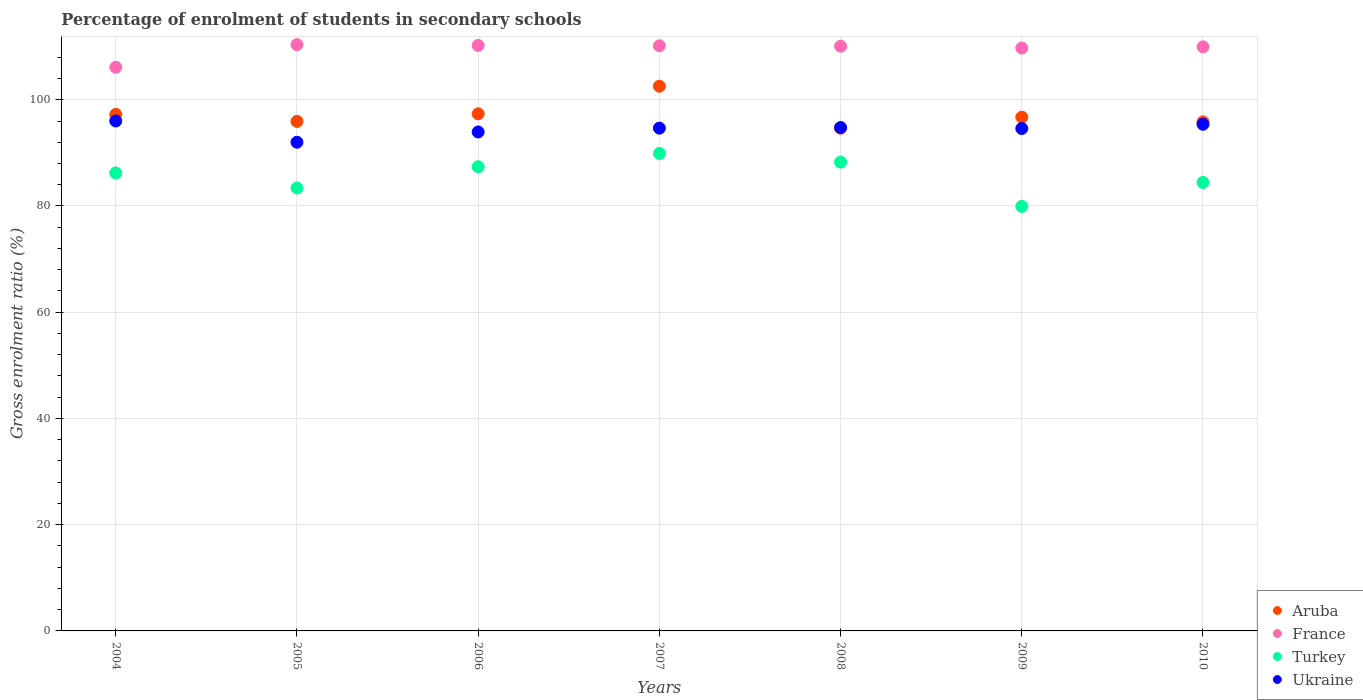How many different coloured dotlines are there?
Provide a short and direct response. 4. What is the percentage of students enrolled in secondary schools in Ukraine in 2007?
Provide a succinct answer. 94.66. Across all years, what is the maximum percentage of students enrolled in secondary schools in Turkey?
Offer a very short reply. 89.89. Across all years, what is the minimum percentage of students enrolled in secondary schools in Turkey?
Your response must be concise. 79.92. In which year was the percentage of students enrolled in secondary schools in Aruba maximum?
Your response must be concise. 2007. In which year was the percentage of students enrolled in secondary schools in Ukraine minimum?
Give a very brief answer. 2005. What is the total percentage of students enrolled in secondary schools in Turkey in the graph?
Offer a very short reply. 599.5. What is the difference between the percentage of students enrolled in secondary schools in Ukraine in 2007 and that in 2008?
Your response must be concise. -0.12. What is the difference between the percentage of students enrolled in secondary schools in Turkey in 2005 and the percentage of students enrolled in secondary schools in France in 2008?
Provide a succinct answer. -26.69. What is the average percentage of students enrolled in secondary schools in France per year?
Offer a very short reply. 109.52. In the year 2007, what is the difference between the percentage of students enrolled in secondary schools in Turkey and percentage of students enrolled in secondary schools in France?
Ensure brevity in your answer.  -20.26. In how many years, is the percentage of students enrolled in secondary schools in Aruba greater than 56 %?
Make the answer very short. 7. What is the ratio of the percentage of students enrolled in secondary schools in Aruba in 2004 to that in 2005?
Your response must be concise. 1.01. Is the percentage of students enrolled in secondary schools in Aruba in 2006 less than that in 2009?
Your answer should be very brief. No. What is the difference between the highest and the second highest percentage of students enrolled in secondary schools in Aruba?
Give a very brief answer. 5.19. What is the difference between the highest and the lowest percentage of students enrolled in secondary schools in Ukraine?
Your response must be concise. 4. Is the sum of the percentage of students enrolled in secondary schools in Turkey in 2008 and 2009 greater than the maximum percentage of students enrolled in secondary schools in France across all years?
Provide a succinct answer. Yes. Is the percentage of students enrolled in secondary schools in Aruba strictly greater than the percentage of students enrolled in secondary schools in Ukraine over the years?
Provide a short and direct response. No. How many years are there in the graph?
Keep it short and to the point. 7. Does the graph contain any zero values?
Offer a terse response. No. Where does the legend appear in the graph?
Make the answer very short. Bottom right. What is the title of the graph?
Give a very brief answer. Percentage of enrolment of students in secondary schools. What is the label or title of the X-axis?
Offer a very short reply. Years. What is the label or title of the Y-axis?
Offer a terse response. Gross enrolment ratio (%). What is the Gross enrolment ratio (%) of Aruba in 2004?
Your answer should be compact. 97.25. What is the Gross enrolment ratio (%) in France in 2004?
Your answer should be compact. 106.12. What is the Gross enrolment ratio (%) in Turkey in 2004?
Provide a short and direct response. 86.22. What is the Gross enrolment ratio (%) of Ukraine in 2004?
Offer a terse response. 96.01. What is the Gross enrolment ratio (%) of Aruba in 2005?
Your answer should be compact. 95.93. What is the Gross enrolment ratio (%) of France in 2005?
Keep it short and to the point. 110.37. What is the Gross enrolment ratio (%) in Turkey in 2005?
Your answer should be very brief. 83.39. What is the Gross enrolment ratio (%) in Ukraine in 2005?
Give a very brief answer. 92. What is the Gross enrolment ratio (%) of Aruba in 2006?
Provide a short and direct response. 97.36. What is the Gross enrolment ratio (%) in France in 2006?
Provide a succinct answer. 110.23. What is the Gross enrolment ratio (%) of Turkey in 2006?
Your response must be concise. 87.38. What is the Gross enrolment ratio (%) of Ukraine in 2006?
Your answer should be very brief. 93.94. What is the Gross enrolment ratio (%) of Aruba in 2007?
Give a very brief answer. 102.55. What is the Gross enrolment ratio (%) in France in 2007?
Your response must be concise. 110.16. What is the Gross enrolment ratio (%) of Turkey in 2007?
Ensure brevity in your answer.  89.89. What is the Gross enrolment ratio (%) of Ukraine in 2007?
Offer a very short reply. 94.66. What is the Gross enrolment ratio (%) of Aruba in 2008?
Offer a very short reply. 94.65. What is the Gross enrolment ratio (%) in France in 2008?
Make the answer very short. 110.08. What is the Gross enrolment ratio (%) of Turkey in 2008?
Give a very brief answer. 88.27. What is the Gross enrolment ratio (%) of Ukraine in 2008?
Your answer should be compact. 94.77. What is the Gross enrolment ratio (%) in Aruba in 2009?
Your response must be concise. 96.72. What is the Gross enrolment ratio (%) of France in 2009?
Ensure brevity in your answer.  109.75. What is the Gross enrolment ratio (%) in Turkey in 2009?
Give a very brief answer. 79.92. What is the Gross enrolment ratio (%) in Ukraine in 2009?
Your answer should be compact. 94.59. What is the Gross enrolment ratio (%) in Aruba in 2010?
Your answer should be compact. 95.84. What is the Gross enrolment ratio (%) in France in 2010?
Offer a very short reply. 109.96. What is the Gross enrolment ratio (%) of Turkey in 2010?
Give a very brief answer. 84.43. What is the Gross enrolment ratio (%) in Ukraine in 2010?
Provide a short and direct response. 95.39. Across all years, what is the maximum Gross enrolment ratio (%) in Aruba?
Keep it short and to the point. 102.55. Across all years, what is the maximum Gross enrolment ratio (%) of France?
Keep it short and to the point. 110.37. Across all years, what is the maximum Gross enrolment ratio (%) in Turkey?
Your response must be concise. 89.89. Across all years, what is the maximum Gross enrolment ratio (%) in Ukraine?
Offer a very short reply. 96.01. Across all years, what is the minimum Gross enrolment ratio (%) of Aruba?
Ensure brevity in your answer.  94.65. Across all years, what is the minimum Gross enrolment ratio (%) of France?
Offer a very short reply. 106.12. Across all years, what is the minimum Gross enrolment ratio (%) of Turkey?
Provide a succinct answer. 79.92. Across all years, what is the minimum Gross enrolment ratio (%) of Ukraine?
Provide a short and direct response. 92. What is the total Gross enrolment ratio (%) of Aruba in the graph?
Keep it short and to the point. 680.29. What is the total Gross enrolment ratio (%) in France in the graph?
Keep it short and to the point. 766.67. What is the total Gross enrolment ratio (%) of Turkey in the graph?
Your response must be concise. 599.5. What is the total Gross enrolment ratio (%) in Ukraine in the graph?
Make the answer very short. 661.35. What is the difference between the Gross enrolment ratio (%) of Aruba in 2004 and that in 2005?
Provide a short and direct response. 1.32. What is the difference between the Gross enrolment ratio (%) of France in 2004 and that in 2005?
Your response must be concise. -4.25. What is the difference between the Gross enrolment ratio (%) of Turkey in 2004 and that in 2005?
Provide a short and direct response. 2.83. What is the difference between the Gross enrolment ratio (%) in Ukraine in 2004 and that in 2005?
Ensure brevity in your answer.  4. What is the difference between the Gross enrolment ratio (%) of Aruba in 2004 and that in 2006?
Your response must be concise. -0.1. What is the difference between the Gross enrolment ratio (%) of France in 2004 and that in 2006?
Keep it short and to the point. -4.1. What is the difference between the Gross enrolment ratio (%) in Turkey in 2004 and that in 2006?
Keep it short and to the point. -1.16. What is the difference between the Gross enrolment ratio (%) of Ukraine in 2004 and that in 2006?
Give a very brief answer. 2.07. What is the difference between the Gross enrolment ratio (%) in Aruba in 2004 and that in 2007?
Your answer should be very brief. -5.29. What is the difference between the Gross enrolment ratio (%) of France in 2004 and that in 2007?
Offer a very short reply. -4.03. What is the difference between the Gross enrolment ratio (%) of Turkey in 2004 and that in 2007?
Provide a succinct answer. -3.67. What is the difference between the Gross enrolment ratio (%) in Ukraine in 2004 and that in 2007?
Provide a succinct answer. 1.35. What is the difference between the Gross enrolment ratio (%) of Aruba in 2004 and that in 2008?
Make the answer very short. 2.6. What is the difference between the Gross enrolment ratio (%) of France in 2004 and that in 2008?
Offer a terse response. -3.96. What is the difference between the Gross enrolment ratio (%) in Turkey in 2004 and that in 2008?
Provide a short and direct response. -2.04. What is the difference between the Gross enrolment ratio (%) in Ukraine in 2004 and that in 2008?
Your answer should be very brief. 1.23. What is the difference between the Gross enrolment ratio (%) in Aruba in 2004 and that in 2009?
Provide a short and direct response. 0.53. What is the difference between the Gross enrolment ratio (%) in France in 2004 and that in 2009?
Give a very brief answer. -3.62. What is the difference between the Gross enrolment ratio (%) of Turkey in 2004 and that in 2009?
Keep it short and to the point. 6.3. What is the difference between the Gross enrolment ratio (%) of Ukraine in 2004 and that in 2009?
Your answer should be very brief. 1.42. What is the difference between the Gross enrolment ratio (%) in Aruba in 2004 and that in 2010?
Your answer should be very brief. 1.42. What is the difference between the Gross enrolment ratio (%) in France in 2004 and that in 2010?
Your answer should be compact. -3.84. What is the difference between the Gross enrolment ratio (%) in Turkey in 2004 and that in 2010?
Your answer should be very brief. 1.79. What is the difference between the Gross enrolment ratio (%) of Ukraine in 2004 and that in 2010?
Make the answer very short. 0.62. What is the difference between the Gross enrolment ratio (%) of Aruba in 2005 and that in 2006?
Ensure brevity in your answer.  -1.43. What is the difference between the Gross enrolment ratio (%) in France in 2005 and that in 2006?
Give a very brief answer. 0.14. What is the difference between the Gross enrolment ratio (%) of Turkey in 2005 and that in 2006?
Your answer should be compact. -4. What is the difference between the Gross enrolment ratio (%) of Ukraine in 2005 and that in 2006?
Keep it short and to the point. -1.93. What is the difference between the Gross enrolment ratio (%) of Aruba in 2005 and that in 2007?
Provide a short and direct response. -6.62. What is the difference between the Gross enrolment ratio (%) in France in 2005 and that in 2007?
Your answer should be compact. 0.22. What is the difference between the Gross enrolment ratio (%) in Turkey in 2005 and that in 2007?
Give a very brief answer. -6.51. What is the difference between the Gross enrolment ratio (%) in Ukraine in 2005 and that in 2007?
Offer a very short reply. -2.65. What is the difference between the Gross enrolment ratio (%) of Aruba in 2005 and that in 2008?
Offer a very short reply. 1.28. What is the difference between the Gross enrolment ratio (%) in France in 2005 and that in 2008?
Your response must be concise. 0.29. What is the difference between the Gross enrolment ratio (%) in Turkey in 2005 and that in 2008?
Provide a succinct answer. -4.88. What is the difference between the Gross enrolment ratio (%) of Ukraine in 2005 and that in 2008?
Your answer should be very brief. -2.77. What is the difference between the Gross enrolment ratio (%) of Aruba in 2005 and that in 2009?
Offer a very short reply. -0.79. What is the difference between the Gross enrolment ratio (%) of France in 2005 and that in 2009?
Keep it short and to the point. 0.63. What is the difference between the Gross enrolment ratio (%) in Turkey in 2005 and that in 2009?
Offer a terse response. 3.46. What is the difference between the Gross enrolment ratio (%) of Ukraine in 2005 and that in 2009?
Your answer should be compact. -2.58. What is the difference between the Gross enrolment ratio (%) of Aruba in 2005 and that in 2010?
Provide a short and direct response. 0.09. What is the difference between the Gross enrolment ratio (%) of France in 2005 and that in 2010?
Your answer should be very brief. 0.41. What is the difference between the Gross enrolment ratio (%) in Turkey in 2005 and that in 2010?
Offer a very short reply. -1.04. What is the difference between the Gross enrolment ratio (%) in Ukraine in 2005 and that in 2010?
Provide a succinct answer. -3.39. What is the difference between the Gross enrolment ratio (%) in Aruba in 2006 and that in 2007?
Provide a succinct answer. -5.19. What is the difference between the Gross enrolment ratio (%) of France in 2006 and that in 2007?
Provide a succinct answer. 0.07. What is the difference between the Gross enrolment ratio (%) of Turkey in 2006 and that in 2007?
Your response must be concise. -2.51. What is the difference between the Gross enrolment ratio (%) in Ukraine in 2006 and that in 2007?
Ensure brevity in your answer.  -0.72. What is the difference between the Gross enrolment ratio (%) of Aruba in 2006 and that in 2008?
Provide a short and direct response. 2.71. What is the difference between the Gross enrolment ratio (%) of France in 2006 and that in 2008?
Make the answer very short. 0.15. What is the difference between the Gross enrolment ratio (%) of Turkey in 2006 and that in 2008?
Your answer should be compact. -0.88. What is the difference between the Gross enrolment ratio (%) in Ukraine in 2006 and that in 2008?
Ensure brevity in your answer.  -0.83. What is the difference between the Gross enrolment ratio (%) in Aruba in 2006 and that in 2009?
Ensure brevity in your answer.  0.63. What is the difference between the Gross enrolment ratio (%) of France in 2006 and that in 2009?
Ensure brevity in your answer.  0.48. What is the difference between the Gross enrolment ratio (%) of Turkey in 2006 and that in 2009?
Make the answer very short. 7.46. What is the difference between the Gross enrolment ratio (%) of Ukraine in 2006 and that in 2009?
Provide a short and direct response. -0.65. What is the difference between the Gross enrolment ratio (%) of Aruba in 2006 and that in 2010?
Give a very brief answer. 1.52. What is the difference between the Gross enrolment ratio (%) in France in 2006 and that in 2010?
Give a very brief answer. 0.26. What is the difference between the Gross enrolment ratio (%) of Turkey in 2006 and that in 2010?
Your response must be concise. 2.96. What is the difference between the Gross enrolment ratio (%) in Ukraine in 2006 and that in 2010?
Offer a very short reply. -1.45. What is the difference between the Gross enrolment ratio (%) in Aruba in 2007 and that in 2008?
Ensure brevity in your answer.  7.9. What is the difference between the Gross enrolment ratio (%) of France in 2007 and that in 2008?
Your answer should be very brief. 0.08. What is the difference between the Gross enrolment ratio (%) of Turkey in 2007 and that in 2008?
Offer a very short reply. 1.63. What is the difference between the Gross enrolment ratio (%) of Ukraine in 2007 and that in 2008?
Make the answer very short. -0.12. What is the difference between the Gross enrolment ratio (%) of Aruba in 2007 and that in 2009?
Your answer should be very brief. 5.82. What is the difference between the Gross enrolment ratio (%) of France in 2007 and that in 2009?
Keep it short and to the point. 0.41. What is the difference between the Gross enrolment ratio (%) in Turkey in 2007 and that in 2009?
Provide a succinct answer. 9.97. What is the difference between the Gross enrolment ratio (%) in Ukraine in 2007 and that in 2009?
Give a very brief answer. 0.07. What is the difference between the Gross enrolment ratio (%) in Aruba in 2007 and that in 2010?
Your answer should be compact. 6.71. What is the difference between the Gross enrolment ratio (%) of France in 2007 and that in 2010?
Your answer should be very brief. 0.19. What is the difference between the Gross enrolment ratio (%) in Turkey in 2007 and that in 2010?
Your response must be concise. 5.47. What is the difference between the Gross enrolment ratio (%) of Ukraine in 2007 and that in 2010?
Make the answer very short. -0.74. What is the difference between the Gross enrolment ratio (%) in Aruba in 2008 and that in 2009?
Your answer should be compact. -2.07. What is the difference between the Gross enrolment ratio (%) in France in 2008 and that in 2009?
Give a very brief answer. 0.34. What is the difference between the Gross enrolment ratio (%) in Turkey in 2008 and that in 2009?
Your answer should be compact. 8.34. What is the difference between the Gross enrolment ratio (%) of Ukraine in 2008 and that in 2009?
Your answer should be very brief. 0.19. What is the difference between the Gross enrolment ratio (%) in Aruba in 2008 and that in 2010?
Provide a succinct answer. -1.19. What is the difference between the Gross enrolment ratio (%) of France in 2008 and that in 2010?
Provide a short and direct response. 0.12. What is the difference between the Gross enrolment ratio (%) in Turkey in 2008 and that in 2010?
Make the answer very short. 3.84. What is the difference between the Gross enrolment ratio (%) of Ukraine in 2008 and that in 2010?
Ensure brevity in your answer.  -0.62. What is the difference between the Gross enrolment ratio (%) in Aruba in 2009 and that in 2010?
Offer a terse response. 0.89. What is the difference between the Gross enrolment ratio (%) of France in 2009 and that in 2010?
Offer a terse response. -0.22. What is the difference between the Gross enrolment ratio (%) in Turkey in 2009 and that in 2010?
Ensure brevity in your answer.  -4.5. What is the difference between the Gross enrolment ratio (%) of Ukraine in 2009 and that in 2010?
Keep it short and to the point. -0.81. What is the difference between the Gross enrolment ratio (%) in Aruba in 2004 and the Gross enrolment ratio (%) in France in 2005?
Your answer should be very brief. -13.12. What is the difference between the Gross enrolment ratio (%) of Aruba in 2004 and the Gross enrolment ratio (%) of Turkey in 2005?
Give a very brief answer. 13.87. What is the difference between the Gross enrolment ratio (%) of Aruba in 2004 and the Gross enrolment ratio (%) of Ukraine in 2005?
Make the answer very short. 5.25. What is the difference between the Gross enrolment ratio (%) in France in 2004 and the Gross enrolment ratio (%) in Turkey in 2005?
Your answer should be very brief. 22.74. What is the difference between the Gross enrolment ratio (%) of France in 2004 and the Gross enrolment ratio (%) of Ukraine in 2005?
Make the answer very short. 14.12. What is the difference between the Gross enrolment ratio (%) in Turkey in 2004 and the Gross enrolment ratio (%) in Ukraine in 2005?
Offer a very short reply. -5.78. What is the difference between the Gross enrolment ratio (%) in Aruba in 2004 and the Gross enrolment ratio (%) in France in 2006?
Give a very brief answer. -12.98. What is the difference between the Gross enrolment ratio (%) of Aruba in 2004 and the Gross enrolment ratio (%) of Turkey in 2006?
Provide a short and direct response. 9.87. What is the difference between the Gross enrolment ratio (%) in Aruba in 2004 and the Gross enrolment ratio (%) in Ukraine in 2006?
Offer a terse response. 3.31. What is the difference between the Gross enrolment ratio (%) of France in 2004 and the Gross enrolment ratio (%) of Turkey in 2006?
Ensure brevity in your answer.  18.74. What is the difference between the Gross enrolment ratio (%) of France in 2004 and the Gross enrolment ratio (%) of Ukraine in 2006?
Your response must be concise. 12.19. What is the difference between the Gross enrolment ratio (%) of Turkey in 2004 and the Gross enrolment ratio (%) of Ukraine in 2006?
Ensure brevity in your answer.  -7.72. What is the difference between the Gross enrolment ratio (%) of Aruba in 2004 and the Gross enrolment ratio (%) of France in 2007?
Offer a very short reply. -12.91. What is the difference between the Gross enrolment ratio (%) in Aruba in 2004 and the Gross enrolment ratio (%) in Turkey in 2007?
Offer a terse response. 7.36. What is the difference between the Gross enrolment ratio (%) in Aruba in 2004 and the Gross enrolment ratio (%) in Ukraine in 2007?
Provide a short and direct response. 2.6. What is the difference between the Gross enrolment ratio (%) of France in 2004 and the Gross enrolment ratio (%) of Turkey in 2007?
Your answer should be compact. 16.23. What is the difference between the Gross enrolment ratio (%) in France in 2004 and the Gross enrolment ratio (%) in Ukraine in 2007?
Your answer should be compact. 11.47. What is the difference between the Gross enrolment ratio (%) in Turkey in 2004 and the Gross enrolment ratio (%) in Ukraine in 2007?
Provide a succinct answer. -8.43. What is the difference between the Gross enrolment ratio (%) in Aruba in 2004 and the Gross enrolment ratio (%) in France in 2008?
Make the answer very short. -12.83. What is the difference between the Gross enrolment ratio (%) of Aruba in 2004 and the Gross enrolment ratio (%) of Turkey in 2008?
Offer a terse response. 8.99. What is the difference between the Gross enrolment ratio (%) in Aruba in 2004 and the Gross enrolment ratio (%) in Ukraine in 2008?
Offer a very short reply. 2.48. What is the difference between the Gross enrolment ratio (%) of France in 2004 and the Gross enrolment ratio (%) of Turkey in 2008?
Make the answer very short. 17.86. What is the difference between the Gross enrolment ratio (%) of France in 2004 and the Gross enrolment ratio (%) of Ukraine in 2008?
Provide a succinct answer. 11.35. What is the difference between the Gross enrolment ratio (%) of Turkey in 2004 and the Gross enrolment ratio (%) of Ukraine in 2008?
Keep it short and to the point. -8.55. What is the difference between the Gross enrolment ratio (%) of Aruba in 2004 and the Gross enrolment ratio (%) of France in 2009?
Offer a terse response. -12.49. What is the difference between the Gross enrolment ratio (%) in Aruba in 2004 and the Gross enrolment ratio (%) in Turkey in 2009?
Your answer should be very brief. 17.33. What is the difference between the Gross enrolment ratio (%) in Aruba in 2004 and the Gross enrolment ratio (%) in Ukraine in 2009?
Keep it short and to the point. 2.67. What is the difference between the Gross enrolment ratio (%) in France in 2004 and the Gross enrolment ratio (%) in Turkey in 2009?
Provide a succinct answer. 26.2. What is the difference between the Gross enrolment ratio (%) of France in 2004 and the Gross enrolment ratio (%) of Ukraine in 2009?
Your response must be concise. 11.54. What is the difference between the Gross enrolment ratio (%) of Turkey in 2004 and the Gross enrolment ratio (%) of Ukraine in 2009?
Keep it short and to the point. -8.37. What is the difference between the Gross enrolment ratio (%) of Aruba in 2004 and the Gross enrolment ratio (%) of France in 2010?
Ensure brevity in your answer.  -12.71. What is the difference between the Gross enrolment ratio (%) in Aruba in 2004 and the Gross enrolment ratio (%) in Turkey in 2010?
Ensure brevity in your answer.  12.82. What is the difference between the Gross enrolment ratio (%) of Aruba in 2004 and the Gross enrolment ratio (%) of Ukraine in 2010?
Your answer should be compact. 1.86. What is the difference between the Gross enrolment ratio (%) in France in 2004 and the Gross enrolment ratio (%) in Turkey in 2010?
Offer a very short reply. 21.7. What is the difference between the Gross enrolment ratio (%) of France in 2004 and the Gross enrolment ratio (%) of Ukraine in 2010?
Your answer should be compact. 10.73. What is the difference between the Gross enrolment ratio (%) in Turkey in 2004 and the Gross enrolment ratio (%) in Ukraine in 2010?
Make the answer very short. -9.17. What is the difference between the Gross enrolment ratio (%) in Aruba in 2005 and the Gross enrolment ratio (%) in France in 2006?
Your answer should be compact. -14.3. What is the difference between the Gross enrolment ratio (%) in Aruba in 2005 and the Gross enrolment ratio (%) in Turkey in 2006?
Give a very brief answer. 8.55. What is the difference between the Gross enrolment ratio (%) of Aruba in 2005 and the Gross enrolment ratio (%) of Ukraine in 2006?
Provide a short and direct response. 1.99. What is the difference between the Gross enrolment ratio (%) in France in 2005 and the Gross enrolment ratio (%) in Turkey in 2006?
Your answer should be compact. 22.99. What is the difference between the Gross enrolment ratio (%) in France in 2005 and the Gross enrolment ratio (%) in Ukraine in 2006?
Provide a short and direct response. 16.44. What is the difference between the Gross enrolment ratio (%) in Turkey in 2005 and the Gross enrolment ratio (%) in Ukraine in 2006?
Ensure brevity in your answer.  -10.55. What is the difference between the Gross enrolment ratio (%) in Aruba in 2005 and the Gross enrolment ratio (%) in France in 2007?
Offer a very short reply. -14.23. What is the difference between the Gross enrolment ratio (%) of Aruba in 2005 and the Gross enrolment ratio (%) of Turkey in 2007?
Ensure brevity in your answer.  6.04. What is the difference between the Gross enrolment ratio (%) of Aruba in 2005 and the Gross enrolment ratio (%) of Ukraine in 2007?
Offer a terse response. 1.27. What is the difference between the Gross enrolment ratio (%) in France in 2005 and the Gross enrolment ratio (%) in Turkey in 2007?
Keep it short and to the point. 20.48. What is the difference between the Gross enrolment ratio (%) of France in 2005 and the Gross enrolment ratio (%) of Ukraine in 2007?
Ensure brevity in your answer.  15.72. What is the difference between the Gross enrolment ratio (%) of Turkey in 2005 and the Gross enrolment ratio (%) of Ukraine in 2007?
Offer a terse response. -11.27. What is the difference between the Gross enrolment ratio (%) in Aruba in 2005 and the Gross enrolment ratio (%) in France in 2008?
Provide a short and direct response. -14.15. What is the difference between the Gross enrolment ratio (%) of Aruba in 2005 and the Gross enrolment ratio (%) of Turkey in 2008?
Keep it short and to the point. 7.66. What is the difference between the Gross enrolment ratio (%) of Aruba in 2005 and the Gross enrolment ratio (%) of Ukraine in 2008?
Your answer should be compact. 1.16. What is the difference between the Gross enrolment ratio (%) of France in 2005 and the Gross enrolment ratio (%) of Turkey in 2008?
Ensure brevity in your answer.  22.11. What is the difference between the Gross enrolment ratio (%) of France in 2005 and the Gross enrolment ratio (%) of Ukraine in 2008?
Your answer should be very brief. 15.6. What is the difference between the Gross enrolment ratio (%) in Turkey in 2005 and the Gross enrolment ratio (%) in Ukraine in 2008?
Offer a terse response. -11.39. What is the difference between the Gross enrolment ratio (%) of Aruba in 2005 and the Gross enrolment ratio (%) of France in 2009?
Your answer should be very brief. -13.82. What is the difference between the Gross enrolment ratio (%) of Aruba in 2005 and the Gross enrolment ratio (%) of Turkey in 2009?
Your answer should be compact. 16. What is the difference between the Gross enrolment ratio (%) in Aruba in 2005 and the Gross enrolment ratio (%) in Ukraine in 2009?
Offer a terse response. 1.34. What is the difference between the Gross enrolment ratio (%) in France in 2005 and the Gross enrolment ratio (%) in Turkey in 2009?
Give a very brief answer. 30.45. What is the difference between the Gross enrolment ratio (%) of France in 2005 and the Gross enrolment ratio (%) of Ukraine in 2009?
Your response must be concise. 15.79. What is the difference between the Gross enrolment ratio (%) in Turkey in 2005 and the Gross enrolment ratio (%) in Ukraine in 2009?
Give a very brief answer. -11.2. What is the difference between the Gross enrolment ratio (%) of Aruba in 2005 and the Gross enrolment ratio (%) of France in 2010?
Keep it short and to the point. -14.04. What is the difference between the Gross enrolment ratio (%) of Aruba in 2005 and the Gross enrolment ratio (%) of Turkey in 2010?
Keep it short and to the point. 11.5. What is the difference between the Gross enrolment ratio (%) of Aruba in 2005 and the Gross enrolment ratio (%) of Ukraine in 2010?
Offer a terse response. 0.54. What is the difference between the Gross enrolment ratio (%) of France in 2005 and the Gross enrolment ratio (%) of Turkey in 2010?
Your response must be concise. 25.94. What is the difference between the Gross enrolment ratio (%) of France in 2005 and the Gross enrolment ratio (%) of Ukraine in 2010?
Make the answer very short. 14.98. What is the difference between the Gross enrolment ratio (%) in Turkey in 2005 and the Gross enrolment ratio (%) in Ukraine in 2010?
Keep it short and to the point. -12. What is the difference between the Gross enrolment ratio (%) of Aruba in 2006 and the Gross enrolment ratio (%) of France in 2007?
Your response must be concise. -12.8. What is the difference between the Gross enrolment ratio (%) in Aruba in 2006 and the Gross enrolment ratio (%) in Turkey in 2007?
Ensure brevity in your answer.  7.46. What is the difference between the Gross enrolment ratio (%) in Aruba in 2006 and the Gross enrolment ratio (%) in Ukraine in 2007?
Make the answer very short. 2.7. What is the difference between the Gross enrolment ratio (%) of France in 2006 and the Gross enrolment ratio (%) of Turkey in 2007?
Ensure brevity in your answer.  20.33. What is the difference between the Gross enrolment ratio (%) of France in 2006 and the Gross enrolment ratio (%) of Ukraine in 2007?
Your answer should be very brief. 15.57. What is the difference between the Gross enrolment ratio (%) in Turkey in 2006 and the Gross enrolment ratio (%) in Ukraine in 2007?
Provide a succinct answer. -7.27. What is the difference between the Gross enrolment ratio (%) of Aruba in 2006 and the Gross enrolment ratio (%) of France in 2008?
Offer a very short reply. -12.73. What is the difference between the Gross enrolment ratio (%) in Aruba in 2006 and the Gross enrolment ratio (%) in Turkey in 2008?
Your answer should be compact. 9.09. What is the difference between the Gross enrolment ratio (%) in Aruba in 2006 and the Gross enrolment ratio (%) in Ukraine in 2008?
Give a very brief answer. 2.58. What is the difference between the Gross enrolment ratio (%) in France in 2006 and the Gross enrolment ratio (%) in Turkey in 2008?
Your answer should be compact. 21.96. What is the difference between the Gross enrolment ratio (%) in France in 2006 and the Gross enrolment ratio (%) in Ukraine in 2008?
Your response must be concise. 15.46. What is the difference between the Gross enrolment ratio (%) of Turkey in 2006 and the Gross enrolment ratio (%) of Ukraine in 2008?
Your answer should be compact. -7.39. What is the difference between the Gross enrolment ratio (%) of Aruba in 2006 and the Gross enrolment ratio (%) of France in 2009?
Provide a short and direct response. -12.39. What is the difference between the Gross enrolment ratio (%) of Aruba in 2006 and the Gross enrolment ratio (%) of Turkey in 2009?
Make the answer very short. 17.43. What is the difference between the Gross enrolment ratio (%) of Aruba in 2006 and the Gross enrolment ratio (%) of Ukraine in 2009?
Your answer should be very brief. 2.77. What is the difference between the Gross enrolment ratio (%) in France in 2006 and the Gross enrolment ratio (%) in Turkey in 2009?
Make the answer very short. 30.3. What is the difference between the Gross enrolment ratio (%) of France in 2006 and the Gross enrolment ratio (%) of Ukraine in 2009?
Your answer should be compact. 15.64. What is the difference between the Gross enrolment ratio (%) in Turkey in 2006 and the Gross enrolment ratio (%) in Ukraine in 2009?
Provide a succinct answer. -7.2. What is the difference between the Gross enrolment ratio (%) in Aruba in 2006 and the Gross enrolment ratio (%) in France in 2010?
Your answer should be very brief. -12.61. What is the difference between the Gross enrolment ratio (%) of Aruba in 2006 and the Gross enrolment ratio (%) of Turkey in 2010?
Provide a short and direct response. 12.93. What is the difference between the Gross enrolment ratio (%) in Aruba in 2006 and the Gross enrolment ratio (%) in Ukraine in 2010?
Offer a terse response. 1.97. What is the difference between the Gross enrolment ratio (%) of France in 2006 and the Gross enrolment ratio (%) of Turkey in 2010?
Your answer should be very brief. 25.8. What is the difference between the Gross enrolment ratio (%) in France in 2006 and the Gross enrolment ratio (%) in Ukraine in 2010?
Provide a succinct answer. 14.84. What is the difference between the Gross enrolment ratio (%) of Turkey in 2006 and the Gross enrolment ratio (%) of Ukraine in 2010?
Provide a succinct answer. -8.01. What is the difference between the Gross enrolment ratio (%) of Aruba in 2007 and the Gross enrolment ratio (%) of France in 2008?
Your response must be concise. -7.54. What is the difference between the Gross enrolment ratio (%) in Aruba in 2007 and the Gross enrolment ratio (%) in Turkey in 2008?
Provide a short and direct response. 14.28. What is the difference between the Gross enrolment ratio (%) of Aruba in 2007 and the Gross enrolment ratio (%) of Ukraine in 2008?
Your response must be concise. 7.77. What is the difference between the Gross enrolment ratio (%) in France in 2007 and the Gross enrolment ratio (%) in Turkey in 2008?
Ensure brevity in your answer.  21.89. What is the difference between the Gross enrolment ratio (%) of France in 2007 and the Gross enrolment ratio (%) of Ukraine in 2008?
Give a very brief answer. 15.38. What is the difference between the Gross enrolment ratio (%) in Turkey in 2007 and the Gross enrolment ratio (%) in Ukraine in 2008?
Your response must be concise. -4.88. What is the difference between the Gross enrolment ratio (%) of Aruba in 2007 and the Gross enrolment ratio (%) of France in 2009?
Provide a short and direct response. -7.2. What is the difference between the Gross enrolment ratio (%) in Aruba in 2007 and the Gross enrolment ratio (%) in Turkey in 2009?
Provide a succinct answer. 22.62. What is the difference between the Gross enrolment ratio (%) of Aruba in 2007 and the Gross enrolment ratio (%) of Ukraine in 2009?
Your answer should be very brief. 7.96. What is the difference between the Gross enrolment ratio (%) in France in 2007 and the Gross enrolment ratio (%) in Turkey in 2009?
Provide a short and direct response. 30.23. What is the difference between the Gross enrolment ratio (%) of France in 2007 and the Gross enrolment ratio (%) of Ukraine in 2009?
Provide a short and direct response. 15.57. What is the difference between the Gross enrolment ratio (%) of Turkey in 2007 and the Gross enrolment ratio (%) of Ukraine in 2009?
Your response must be concise. -4.69. What is the difference between the Gross enrolment ratio (%) of Aruba in 2007 and the Gross enrolment ratio (%) of France in 2010?
Give a very brief answer. -7.42. What is the difference between the Gross enrolment ratio (%) in Aruba in 2007 and the Gross enrolment ratio (%) in Turkey in 2010?
Give a very brief answer. 18.12. What is the difference between the Gross enrolment ratio (%) of Aruba in 2007 and the Gross enrolment ratio (%) of Ukraine in 2010?
Your answer should be very brief. 7.16. What is the difference between the Gross enrolment ratio (%) of France in 2007 and the Gross enrolment ratio (%) of Turkey in 2010?
Provide a short and direct response. 25.73. What is the difference between the Gross enrolment ratio (%) in France in 2007 and the Gross enrolment ratio (%) in Ukraine in 2010?
Your answer should be very brief. 14.77. What is the difference between the Gross enrolment ratio (%) in Turkey in 2007 and the Gross enrolment ratio (%) in Ukraine in 2010?
Make the answer very short. -5.5. What is the difference between the Gross enrolment ratio (%) of Aruba in 2008 and the Gross enrolment ratio (%) of France in 2009?
Provide a short and direct response. -15.1. What is the difference between the Gross enrolment ratio (%) in Aruba in 2008 and the Gross enrolment ratio (%) in Turkey in 2009?
Make the answer very short. 14.72. What is the difference between the Gross enrolment ratio (%) in Aruba in 2008 and the Gross enrolment ratio (%) in Ukraine in 2009?
Provide a short and direct response. 0.06. What is the difference between the Gross enrolment ratio (%) of France in 2008 and the Gross enrolment ratio (%) of Turkey in 2009?
Make the answer very short. 30.16. What is the difference between the Gross enrolment ratio (%) of France in 2008 and the Gross enrolment ratio (%) of Ukraine in 2009?
Keep it short and to the point. 15.5. What is the difference between the Gross enrolment ratio (%) of Turkey in 2008 and the Gross enrolment ratio (%) of Ukraine in 2009?
Your answer should be compact. -6.32. What is the difference between the Gross enrolment ratio (%) of Aruba in 2008 and the Gross enrolment ratio (%) of France in 2010?
Provide a succinct answer. -15.31. What is the difference between the Gross enrolment ratio (%) of Aruba in 2008 and the Gross enrolment ratio (%) of Turkey in 2010?
Ensure brevity in your answer.  10.22. What is the difference between the Gross enrolment ratio (%) of Aruba in 2008 and the Gross enrolment ratio (%) of Ukraine in 2010?
Your answer should be very brief. -0.74. What is the difference between the Gross enrolment ratio (%) in France in 2008 and the Gross enrolment ratio (%) in Turkey in 2010?
Keep it short and to the point. 25.65. What is the difference between the Gross enrolment ratio (%) of France in 2008 and the Gross enrolment ratio (%) of Ukraine in 2010?
Offer a terse response. 14.69. What is the difference between the Gross enrolment ratio (%) of Turkey in 2008 and the Gross enrolment ratio (%) of Ukraine in 2010?
Provide a succinct answer. -7.13. What is the difference between the Gross enrolment ratio (%) in Aruba in 2009 and the Gross enrolment ratio (%) in France in 2010?
Your response must be concise. -13.24. What is the difference between the Gross enrolment ratio (%) in Aruba in 2009 and the Gross enrolment ratio (%) in Turkey in 2010?
Provide a short and direct response. 12.3. What is the difference between the Gross enrolment ratio (%) of Aruba in 2009 and the Gross enrolment ratio (%) of Ukraine in 2010?
Provide a succinct answer. 1.33. What is the difference between the Gross enrolment ratio (%) of France in 2009 and the Gross enrolment ratio (%) of Turkey in 2010?
Provide a short and direct response. 25.32. What is the difference between the Gross enrolment ratio (%) of France in 2009 and the Gross enrolment ratio (%) of Ukraine in 2010?
Provide a succinct answer. 14.36. What is the difference between the Gross enrolment ratio (%) of Turkey in 2009 and the Gross enrolment ratio (%) of Ukraine in 2010?
Provide a succinct answer. -15.47. What is the average Gross enrolment ratio (%) in Aruba per year?
Offer a terse response. 97.18. What is the average Gross enrolment ratio (%) of France per year?
Provide a succinct answer. 109.52. What is the average Gross enrolment ratio (%) of Turkey per year?
Offer a terse response. 85.64. What is the average Gross enrolment ratio (%) of Ukraine per year?
Your response must be concise. 94.48. In the year 2004, what is the difference between the Gross enrolment ratio (%) of Aruba and Gross enrolment ratio (%) of France?
Offer a terse response. -8.87. In the year 2004, what is the difference between the Gross enrolment ratio (%) in Aruba and Gross enrolment ratio (%) in Turkey?
Your answer should be compact. 11.03. In the year 2004, what is the difference between the Gross enrolment ratio (%) of Aruba and Gross enrolment ratio (%) of Ukraine?
Give a very brief answer. 1.25. In the year 2004, what is the difference between the Gross enrolment ratio (%) in France and Gross enrolment ratio (%) in Turkey?
Ensure brevity in your answer.  19.9. In the year 2004, what is the difference between the Gross enrolment ratio (%) in France and Gross enrolment ratio (%) in Ukraine?
Keep it short and to the point. 10.12. In the year 2004, what is the difference between the Gross enrolment ratio (%) of Turkey and Gross enrolment ratio (%) of Ukraine?
Give a very brief answer. -9.79. In the year 2005, what is the difference between the Gross enrolment ratio (%) of Aruba and Gross enrolment ratio (%) of France?
Make the answer very short. -14.44. In the year 2005, what is the difference between the Gross enrolment ratio (%) of Aruba and Gross enrolment ratio (%) of Turkey?
Make the answer very short. 12.54. In the year 2005, what is the difference between the Gross enrolment ratio (%) in Aruba and Gross enrolment ratio (%) in Ukraine?
Provide a succinct answer. 3.92. In the year 2005, what is the difference between the Gross enrolment ratio (%) of France and Gross enrolment ratio (%) of Turkey?
Provide a succinct answer. 26.99. In the year 2005, what is the difference between the Gross enrolment ratio (%) of France and Gross enrolment ratio (%) of Ukraine?
Your answer should be compact. 18.37. In the year 2005, what is the difference between the Gross enrolment ratio (%) in Turkey and Gross enrolment ratio (%) in Ukraine?
Give a very brief answer. -8.62. In the year 2006, what is the difference between the Gross enrolment ratio (%) of Aruba and Gross enrolment ratio (%) of France?
Offer a terse response. -12.87. In the year 2006, what is the difference between the Gross enrolment ratio (%) of Aruba and Gross enrolment ratio (%) of Turkey?
Provide a succinct answer. 9.97. In the year 2006, what is the difference between the Gross enrolment ratio (%) in Aruba and Gross enrolment ratio (%) in Ukraine?
Offer a terse response. 3.42. In the year 2006, what is the difference between the Gross enrolment ratio (%) in France and Gross enrolment ratio (%) in Turkey?
Your answer should be very brief. 22.84. In the year 2006, what is the difference between the Gross enrolment ratio (%) of France and Gross enrolment ratio (%) of Ukraine?
Provide a short and direct response. 16.29. In the year 2006, what is the difference between the Gross enrolment ratio (%) of Turkey and Gross enrolment ratio (%) of Ukraine?
Keep it short and to the point. -6.55. In the year 2007, what is the difference between the Gross enrolment ratio (%) of Aruba and Gross enrolment ratio (%) of France?
Offer a terse response. -7.61. In the year 2007, what is the difference between the Gross enrolment ratio (%) in Aruba and Gross enrolment ratio (%) in Turkey?
Ensure brevity in your answer.  12.65. In the year 2007, what is the difference between the Gross enrolment ratio (%) in Aruba and Gross enrolment ratio (%) in Ukraine?
Your answer should be compact. 7.89. In the year 2007, what is the difference between the Gross enrolment ratio (%) in France and Gross enrolment ratio (%) in Turkey?
Provide a short and direct response. 20.26. In the year 2007, what is the difference between the Gross enrolment ratio (%) in France and Gross enrolment ratio (%) in Ukraine?
Your answer should be very brief. 15.5. In the year 2007, what is the difference between the Gross enrolment ratio (%) in Turkey and Gross enrolment ratio (%) in Ukraine?
Your answer should be very brief. -4.76. In the year 2008, what is the difference between the Gross enrolment ratio (%) in Aruba and Gross enrolment ratio (%) in France?
Your answer should be very brief. -15.43. In the year 2008, what is the difference between the Gross enrolment ratio (%) of Aruba and Gross enrolment ratio (%) of Turkey?
Ensure brevity in your answer.  6.38. In the year 2008, what is the difference between the Gross enrolment ratio (%) in Aruba and Gross enrolment ratio (%) in Ukraine?
Ensure brevity in your answer.  -0.12. In the year 2008, what is the difference between the Gross enrolment ratio (%) of France and Gross enrolment ratio (%) of Turkey?
Offer a terse response. 21.82. In the year 2008, what is the difference between the Gross enrolment ratio (%) in France and Gross enrolment ratio (%) in Ukraine?
Provide a succinct answer. 15.31. In the year 2008, what is the difference between the Gross enrolment ratio (%) of Turkey and Gross enrolment ratio (%) of Ukraine?
Provide a succinct answer. -6.51. In the year 2009, what is the difference between the Gross enrolment ratio (%) in Aruba and Gross enrolment ratio (%) in France?
Your answer should be very brief. -13.02. In the year 2009, what is the difference between the Gross enrolment ratio (%) in Aruba and Gross enrolment ratio (%) in Turkey?
Your answer should be very brief. 16.8. In the year 2009, what is the difference between the Gross enrolment ratio (%) in Aruba and Gross enrolment ratio (%) in Ukraine?
Make the answer very short. 2.14. In the year 2009, what is the difference between the Gross enrolment ratio (%) in France and Gross enrolment ratio (%) in Turkey?
Make the answer very short. 29.82. In the year 2009, what is the difference between the Gross enrolment ratio (%) of France and Gross enrolment ratio (%) of Ukraine?
Provide a short and direct response. 15.16. In the year 2009, what is the difference between the Gross enrolment ratio (%) in Turkey and Gross enrolment ratio (%) in Ukraine?
Keep it short and to the point. -14.66. In the year 2010, what is the difference between the Gross enrolment ratio (%) in Aruba and Gross enrolment ratio (%) in France?
Your answer should be very brief. -14.13. In the year 2010, what is the difference between the Gross enrolment ratio (%) of Aruba and Gross enrolment ratio (%) of Turkey?
Your answer should be very brief. 11.41. In the year 2010, what is the difference between the Gross enrolment ratio (%) in Aruba and Gross enrolment ratio (%) in Ukraine?
Make the answer very short. 0.45. In the year 2010, what is the difference between the Gross enrolment ratio (%) in France and Gross enrolment ratio (%) in Turkey?
Offer a very short reply. 25.54. In the year 2010, what is the difference between the Gross enrolment ratio (%) of France and Gross enrolment ratio (%) of Ukraine?
Your answer should be compact. 14.57. In the year 2010, what is the difference between the Gross enrolment ratio (%) of Turkey and Gross enrolment ratio (%) of Ukraine?
Provide a succinct answer. -10.96. What is the ratio of the Gross enrolment ratio (%) in Aruba in 2004 to that in 2005?
Provide a short and direct response. 1.01. What is the ratio of the Gross enrolment ratio (%) of France in 2004 to that in 2005?
Your answer should be compact. 0.96. What is the ratio of the Gross enrolment ratio (%) in Turkey in 2004 to that in 2005?
Give a very brief answer. 1.03. What is the ratio of the Gross enrolment ratio (%) in Ukraine in 2004 to that in 2005?
Your answer should be very brief. 1.04. What is the ratio of the Gross enrolment ratio (%) of Aruba in 2004 to that in 2006?
Your response must be concise. 1. What is the ratio of the Gross enrolment ratio (%) in France in 2004 to that in 2006?
Your answer should be very brief. 0.96. What is the ratio of the Gross enrolment ratio (%) in Turkey in 2004 to that in 2006?
Provide a short and direct response. 0.99. What is the ratio of the Gross enrolment ratio (%) in Aruba in 2004 to that in 2007?
Give a very brief answer. 0.95. What is the ratio of the Gross enrolment ratio (%) in France in 2004 to that in 2007?
Ensure brevity in your answer.  0.96. What is the ratio of the Gross enrolment ratio (%) of Turkey in 2004 to that in 2007?
Give a very brief answer. 0.96. What is the ratio of the Gross enrolment ratio (%) in Ukraine in 2004 to that in 2007?
Offer a very short reply. 1.01. What is the ratio of the Gross enrolment ratio (%) in Aruba in 2004 to that in 2008?
Ensure brevity in your answer.  1.03. What is the ratio of the Gross enrolment ratio (%) in France in 2004 to that in 2008?
Make the answer very short. 0.96. What is the ratio of the Gross enrolment ratio (%) of Turkey in 2004 to that in 2008?
Offer a very short reply. 0.98. What is the ratio of the Gross enrolment ratio (%) in Ukraine in 2004 to that in 2008?
Your response must be concise. 1.01. What is the ratio of the Gross enrolment ratio (%) in Aruba in 2004 to that in 2009?
Keep it short and to the point. 1.01. What is the ratio of the Gross enrolment ratio (%) of Turkey in 2004 to that in 2009?
Offer a very short reply. 1.08. What is the ratio of the Gross enrolment ratio (%) in Aruba in 2004 to that in 2010?
Offer a very short reply. 1.01. What is the ratio of the Gross enrolment ratio (%) in France in 2004 to that in 2010?
Make the answer very short. 0.97. What is the ratio of the Gross enrolment ratio (%) of Turkey in 2004 to that in 2010?
Provide a short and direct response. 1.02. What is the ratio of the Gross enrolment ratio (%) of Ukraine in 2004 to that in 2010?
Offer a terse response. 1.01. What is the ratio of the Gross enrolment ratio (%) of Turkey in 2005 to that in 2006?
Ensure brevity in your answer.  0.95. What is the ratio of the Gross enrolment ratio (%) of Ukraine in 2005 to that in 2006?
Offer a very short reply. 0.98. What is the ratio of the Gross enrolment ratio (%) of Aruba in 2005 to that in 2007?
Provide a succinct answer. 0.94. What is the ratio of the Gross enrolment ratio (%) in France in 2005 to that in 2007?
Provide a short and direct response. 1. What is the ratio of the Gross enrolment ratio (%) of Turkey in 2005 to that in 2007?
Keep it short and to the point. 0.93. What is the ratio of the Gross enrolment ratio (%) in Aruba in 2005 to that in 2008?
Ensure brevity in your answer.  1.01. What is the ratio of the Gross enrolment ratio (%) of France in 2005 to that in 2008?
Provide a succinct answer. 1. What is the ratio of the Gross enrolment ratio (%) of Turkey in 2005 to that in 2008?
Give a very brief answer. 0.94. What is the ratio of the Gross enrolment ratio (%) of Ukraine in 2005 to that in 2008?
Provide a succinct answer. 0.97. What is the ratio of the Gross enrolment ratio (%) of Aruba in 2005 to that in 2009?
Offer a very short reply. 0.99. What is the ratio of the Gross enrolment ratio (%) of Turkey in 2005 to that in 2009?
Your answer should be very brief. 1.04. What is the ratio of the Gross enrolment ratio (%) in Ukraine in 2005 to that in 2009?
Your answer should be very brief. 0.97. What is the ratio of the Gross enrolment ratio (%) in Aruba in 2005 to that in 2010?
Offer a very short reply. 1. What is the ratio of the Gross enrolment ratio (%) of France in 2005 to that in 2010?
Your response must be concise. 1. What is the ratio of the Gross enrolment ratio (%) in Turkey in 2005 to that in 2010?
Your answer should be compact. 0.99. What is the ratio of the Gross enrolment ratio (%) in Ukraine in 2005 to that in 2010?
Offer a terse response. 0.96. What is the ratio of the Gross enrolment ratio (%) of Aruba in 2006 to that in 2007?
Offer a terse response. 0.95. What is the ratio of the Gross enrolment ratio (%) of Turkey in 2006 to that in 2007?
Provide a short and direct response. 0.97. What is the ratio of the Gross enrolment ratio (%) in Ukraine in 2006 to that in 2007?
Give a very brief answer. 0.99. What is the ratio of the Gross enrolment ratio (%) of Aruba in 2006 to that in 2008?
Provide a succinct answer. 1.03. What is the ratio of the Gross enrolment ratio (%) of Turkey in 2006 to that in 2008?
Ensure brevity in your answer.  0.99. What is the ratio of the Gross enrolment ratio (%) in Ukraine in 2006 to that in 2008?
Keep it short and to the point. 0.99. What is the ratio of the Gross enrolment ratio (%) of Turkey in 2006 to that in 2009?
Your answer should be compact. 1.09. What is the ratio of the Gross enrolment ratio (%) in Aruba in 2006 to that in 2010?
Offer a very short reply. 1.02. What is the ratio of the Gross enrolment ratio (%) of France in 2006 to that in 2010?
Offer a terse response. 1. What is the ratio of the Gross enrolment ratio (%) of Turkey in 2006 to that in 2010?
Keep it short and to the point. 1.03. What is the ratio of the Gross enrolment ratio (%) in Ukraine in 2006 to that in 2010?
Offer a very short reply. 0.98. What is the ratio of the Gross enrolment ratio (%) in Aruba in 2007 to that in 2008?
Provide a short and direct response. 1.08. What is the ratio of the Gross enrolment ratio (%) of France in 2007 to that in 2008?
Offer a terse response. 1. What is the ratio of the Gross enrolment ratio (%) of Turkey in 2007 to that in 2008?
Offer a terse response. 1.02. What is the ratio of the Gross enrolment ratio (%) in Ukraine in 2007 to that in 2008?
Keep it short and to the point. 1. What is the ratio of the Gross enrolment ratio (%) in Aruba in 2007 to that in 2009?
Offer a very short reply. 1.06. What is the ratio of the Gross enrolment ratio (%) in Turkey in 2007 to that in 2009?
Provide a short and direct response. 1.12. What is the ratio of the Gross enrolment ratio (%) in Ukraine in 2007 to that in 2009?
Offer a terse response. 1. What is the ratio of the Gross enrolment ratio (%) of Aruba in 2007 to that in 2010?
Your response must be concise. 1.07. What is the ratio of the Gross enrolment ratio (%) of France in 2007 to that in 2010?
Your response must be concise. 1. What is the ratio of the Gross enrolment ratio (%) in Turkey in 2007 to that in 2010?
Your answer should be compact. 1.06. What is the ratio of the Gross enrolment ratio (%) in Aruba in 2008 to that in 2009?
Offer a very short reply. 0.98. What is the ratio of the Gross enrolment ratio (%) of France in 2008 to that in 2009?
Your response must be concise. 1. What is the ratio of the Gross enrolment ratio (%) of Turkey in 2008 to that in 2009?
Give a very brief answer. 1.1. What is the ratio of the Gross enrolment ratio (%) in Ukraine in 2008 to that in 2009?
Your answer should be compact. 1. What is the ratio of the Gross enrolment ratio (%) in Aruba in 2008 to that in 2010?
Keep it short and to the point. 0.99. What is the ratio of the Gross enrolment ratio (%) of Turkey in 2008 to that in 2010?
Give a very brief answer. 1.05. What is the ratio of the Gross enrolment ratio (%) of Ukraine in 2008 to that in 2010?
Ensure brevity in your answer.  0.99. What is the ratio of the Gross enrolment ratio (%) in Aruba in 2009 to that in 2010?
Give a very brief answer. 1.01. What is the ratio of the Gross enrolment ratio (%) in France in 2009 to that in 2010?
Offer a terse response. 1. What is the ratio of the Gross enrolment ratio (%) of Turkey in 2009 to that in 2010?
Provide a succinct answer. 0.95. What is the difference between the highest and the second highest Gross enrolment ratio (%) in Aruba?
Your answer should be very brief. 5.19. What is the difference between the highest and the second highest Gross enrolment ratio (%) of France?
Give a very brief answer. 0.14. What is the difference between the highest and the second highest Gross enrolment ratio (%) of Turkey?
Your answer should be compact. 1.63. What is the difference between the highest and the second highest Gross enrolment ratio (%) of Ukraine?
Make the answer very short. 0.62. What is the difference between the highest and the lowest Gross enrolment ratio (%) of Aruba?
Give a very brief answer. 7.9. What is the difference between the highest and the lowest Gross enrolment ratio (%) of France?
Make the answer very short. 4.25. What is the difference between the highest and the lowest Gross enrolment ratio (%) in Turkey?
Make the answer very short. 9.97. What is the difference between the highest and the lowest Gross enrolment ratio (%) in Ukraine?
Make the answer very short. 4. 